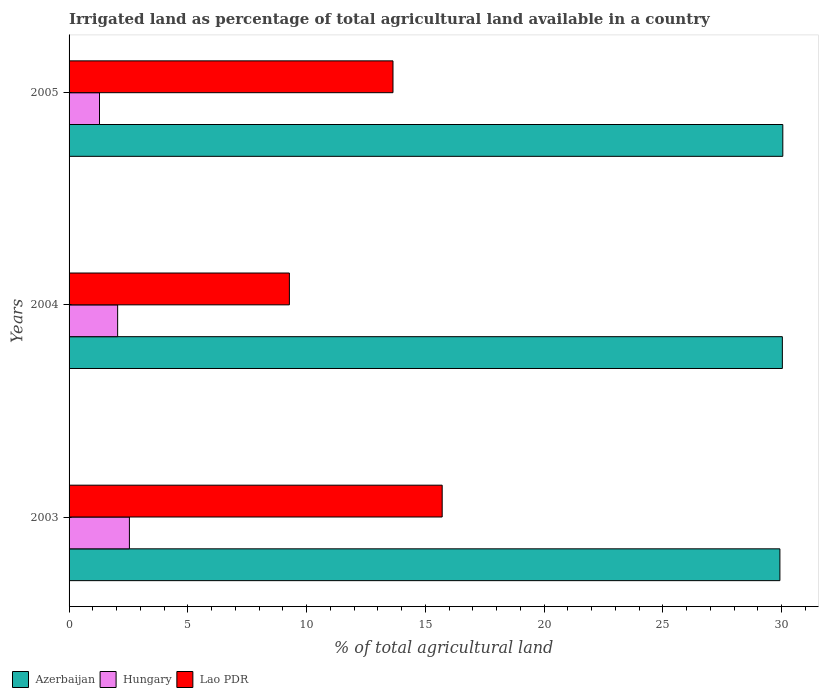How many different coloured bars are there?
Ensure brevity in your answer.  3. Are the number of bars on each tick of the Y-axis equal?
Provide a succinct answer. Yes. How many bars are there on the 3rd tick from the top?
Your answer should be very brief. 3. How many bars are there on the 3rd tick from the bottom?
Your answer should be very brief. 3. What is the percentage of irrigated land in Azerbaijan in 2004?
Provide a short and direct response. 30.03. Across all years, what is the maximum percentage of irrigated land in Hungary?
Give a very brief answer. 2.54. Across all years, what is the minimum percentage of irrigated land in Hungary?
Your answer should be compact. 1.28. In which year was the percentage of irrigated land in Azerbaijan minimum?
Give a very brief answer. 2003. What is the total percentage of irrigated land in Azerbaijan in the graph?
Your response must be concise. 90.01. What is the difference between the percentage of irrigated land in Hungary in 2004 and that in 2005?
Offer a very short reply. 0.76. What is the difference between the percentage of irrigated land in Lao PDR in 2005 and the percentage of irrigated land in Azerbaijan in 2003?
Keep it short and to the point. -16.29. What is the average percentage of irrigated land in Hungary per year?
Offer a very short reply. 1.96. In the year 2003, what is the difference between the percentage of irrigated land in Hungary and percentage of irrigated land in Lao PDR?
Give a very brief answer. -13.17. What is the ratio of the percentage of irrigated land in Hungary in 2004 to that in 2005?
Offer a very short reply. 1.6. Is the percentage of irrigated land in Azerbaijan in 2003 less than that in 2005?
Provide a succinct answer. Yes. What is the difference between the highest and the second highest percentage of irrigated land in Lao PDR?
Give a very brief answer. 2.07. What is the difference between the highest and the lowest percentage of irrigated land in Hungary?
Provide a short and direct response. 1.26. Is the sum of the percentage of irrigated land in Hungary in 2004 and 2005 greater than the maximum percentage of irrigated land in Lao PDR across all years?
Your answer should be compact. No. What does the 2nd bar from the top in 2005 represents?
Offer a very short reply. Hungary. What does the 2nd bar from the bottom in 2003 represents?
Your answer should be compact. Hungary. How many bars are there?
Make the answer very short. 9. How many years are there in the graph?
Give a very brief answer. 3. Are the values on the major ticks of X-axis written in scientific E-notation?
Your answer should be very brief. No. Where does the legend appear in the graph?
Give a very brief answer. Bottom left. What is the title of the graph?
Provide a short and direct response. Irrigated land as percentage of total agricultural land available in a country. Does "Other small states" appear as one of the legend labels in the graph?
Your response must be concise. No. What is the label or title of the X-axis?
Make the answer very short. % of total agricultural land. What is the label or title of the Y-axis?
Your answer should be compact. Years. What is the % of total agricultural land in Azerbaijan in 2003?
Your answer should be compact. 29.93. What is the % of total agricultural land of Hungary in 2003?
Your response must be concise. 2.54. What is the % of total agricultural land in Lao PDR in 2003?
Your answer should be very brief. 15.71. What is the % of total agricultural land of Azerbaijan in 2004?
Your answer should be very brief. 30.03. What is the % of total agricultural land of Hungary in 2004?
Offer a very short reply. 2.05. What is the % of total agricultural land of Lao PDR in 2004?
Your answer should be very brief. 9.28. What is the % of total agricultural land of Azerbaijan in 2005?
Your answer should be very brief. 30.05. What is the % of total agricultural land of Hungary in 2005?
Your response must be concise. 1.28. What is the % of total agricultural land in Lao PDR in 2005?
Provide a short and direct response. 13.64. Across all years, what is the maximum % of total agricultural land of Azerbaijan?
Ensure brevity in your answer.  30.05. Across all years, what is the maximum % of total agricultural land in Hungary?
Your response must be concise. 2.54. Across all years, what is the maximum % of total agricultural land of Lao PDR?
Keep it short and to the point. 15.71. Across all years, what is the minimum % of total agricultural land in Azerbaijan?
Give a very brief answer. 29.93. Across all years, what is the minimum % of total agricultural land in Hungary?
Give a very brief answer. 1.28. Across all years, what is the minimum % of total agricultural land in Lao PDR?
Offer a very short reply. 9.28. What is the total % of total agricultural land in Azerbaijan in the graph?
Offer a terse response. 90.01. What is the total % of total agricultural land of Hungary in the graph?
Provide a succinct answer. 5.87. What is the total % of total agricultural land of Lao PDR in the graph?
Make the answer very short. 38.62. What is the difference between the % of total agricultural land of Azerbaijan in 2003 and that in 2004?
Provide a succinct answer. -0.1. What is the difference between the % of total agricultural land in Hungary in 2003 and that in 2004?
Give a very brief answer. 0.5. What is the difference between the % of total agricultural land in Lao PDR in 2003 and that in 2004?
Your answer should be compact. 6.43. What is the difference between the % of total agricultural land of Azerbaijan in 2003 and that in 2005?
Ensure brevity in your answer.  -0.12. What is the difference between the % of total agricultural land of Hungary in 2003 and that in 2005?
Your response must be concise. 1.26. What is the difference between the % of total agricultural land of Lao PDR in 2003 and that in 2005?
Ensure brevity in your answer.  2.07. What is the difference between the % of total agricultural land of Azerbaijan in 2004 and that in 2005?
Provide a short and direct response. -0.02. What is the difference between the % of total agricultural land in Hungary in 2004 and that in 2005?
Ensure brevity in your answer.  0.76. What is the difference between the % of total agricultural land of Lao PDR in 2004 and that in 2005?
Your answer should be compact. -4.36. What is the difference between the % of total agricultural land in Azerbaijan in 2003 and the % of total agricultural land in Hungary in 2004?
Your answer should be compact. 27.88. What is the difference between the % of total agricultural land in Azerbaijan in 2003 and the % of total agricultural land in Lao PDR in 2004?
Your answer should be very brief. 20.65. What is the difference between the % of total agricultural land in Hungary in 2003 and the % of total agricultural land in Lao PDR in 2004?
Your answer should be very brief. -6.74. What is the difference between the % of total agricultural land in Azerbaijan in 2003 and the % of total agricultural land in Hungary in 2005?
Keep it short and to the point. 28.65. What is the difference between the % of total agricultural land in Azerbaijan in 2003 and the % of total agricultural land in Lao PDR in 2005?
Provide a succinct answer. 16.29. What is the difference between the % of total agricultural land of Hungary in 2003 and the % of total agricultural land of Lao PDR in 2005?
Your response must be concise. -11.1. What is the difference between the % of total agricultural land of Azerbaijan in 2004 and the % of total agricultural land of Hungary in 2005?
Ensure brevity in your answer.  28.75. What is the difference between the % of total agricultural land in Azerbaijan in 2004 and the % of total agricultural land in Lao PDR in 2005?
Keep it short and to the point. 16.39. What is the difference between the % of total agricultural land of Hungary in 2004 and the % of total agricultural land of Lao PDR in 2005?
Provide a succinct answer. -11.59. What is the average % of total agricultural land of Azerbaijan per year?
Your answer should be compact. 30. What is the average % of total agricultural land in Hungary per year?
Ensure brevity in your answer.  1.96. What is the average % of total agricultural land in Lao PDR per year?
Give a very brief answer. 12.87. In the year 2003, what is the difference between the % of total agricultural land in Azerbaijan and % of total agricultural land in Hungary?
Ensure brevity in your answer.  27.39. In the year 2003, what is the difference between the % of total agricultural land of Azerbaijan and % of total agricultural land of Lao PDR?
Make the answer very short. 14.22. In the year 2003, what is the difference between the % of total agricultural land of Hungary and % of total agricultural land of Lao PDR?
Ensure brevity in your answer.  -13.17. In the year 2004, what is the difference between the % of total agricultural land in Azerbaijan and % of total agricultural land in Hungary?
Keep it short and to the point. 27.99. In the year 2004, what is the difference between the % of total agricultural land of Azerbaijan and % of total agricultural land of Lao PDR?
Ensure brevity in your answer.  20.76. In the year 2004, what is the difference between the % of total agricultural land of Hungary and % of total agricultural land of Lao PDR?
Your answer should be compact. -7.23. In the year 2005, what is the difference between the % of total agricultural land in Azerbaijan and % of total agricultural land in Hungary?
Offer a terse response. 28.77. In the year 2005, what is the difference between the % of total agricultural land of Azerbaijan and % of total agricultural land of Lao PDR?
Your answer should be very brief. 16.41. In the year 2005, what is the difference between the % of total agricultural land in Hungary and % of total agricultural land in Lao PDR?
Offer a terse response. -12.36. What is the ratio of the % of total agricultural land of Hungary in 2003 to that in 2004?
Your response must be concise. 1.24. What is the ratio of the % of total agricultural land in Lao PDR in 2003 to that in 2004?
Your answer should be very brief. 1.69. What is the ratio of the % of total agricultural land in Hungary in 2003 to that in 2005?
Offer a terse response. 1.98. What is the ratio of the % of total agricultural land of Lao PDR in 2003 to that in 2005?
Offer a terse response. 1.15. What is the ratio of the % of total agricultural land in Azerbaijan in 2004 to that in 2005?
Keep it short and to the point. 1. What is the ratio of the % of total agricultural land of Hungary in 2004 to that in 2005?
Your answer should be compact. 1.6. What is the ratio of the % of total agricultural land in Lao PDR in 2004 to that in 2005?
Ensure brevity in your answer.  0.68. What is the difference between the highest and the second highest % of total agricultural land in Azerbaijan?
Offer a terse response. 0.02. What is the difference between the highest and the second highest % of total agricultural land of Hungary?
Your response must be concise. 0.5. What is the difference between the highest and the second highest % of total agricultural land in Lao PDR?
Make the answer very short. 2.07. What is the difference between the highest and the lowest % of total agricultural land of Azerbaijan?
Your answer should be compact. 0.12. What is the difference between the highest and the lowest % of total agricultural land of Hungary?
Make the answer very short. 1.26. What is the difference between the highest and the lowest % of total agricultural land of Lao PDR?
Your answer should be compact. 6.43. 